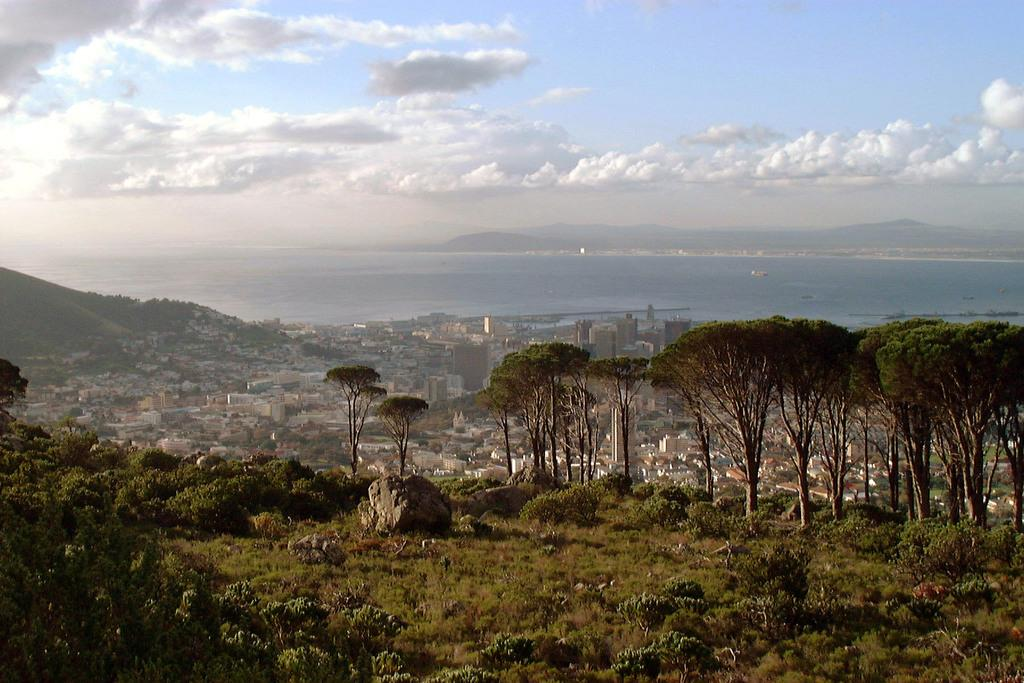What type of vegetation can be seen in the image? There are plants and trees in the image. What type of structures are present in the image? There are buildings in the image. What can be seen in the background of the image? In the background, there is water, hills, and clouds visible. How many apples are hanging from the trees in the image? There are no apples visible in the image; only trees are present. What type of waves can be seen in the image? There are no waves visible in the image; only water is present in the background. 